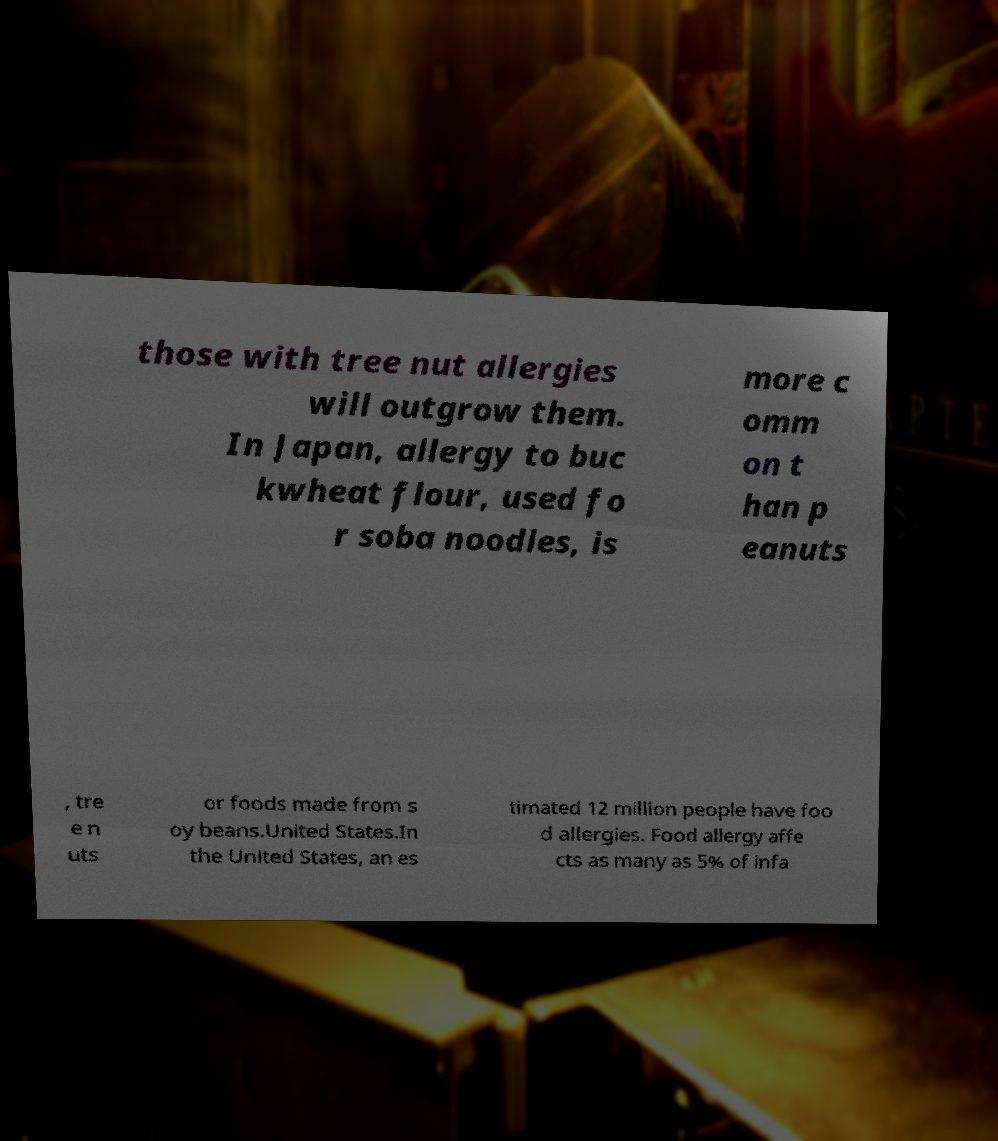I need the written content from this picture converted into text. Can you do that? those with tree nut allergies will outgrow them. In Japan, allergy to buc kwheat flour, used fo r soba noodles, is more c omm on t han p eanuts , tre e n uts or foods made from s oy beans.United States.In the United States, an es timated 12 million people have foo d allergies. Food allergy affe cts as many as 5% of infa 